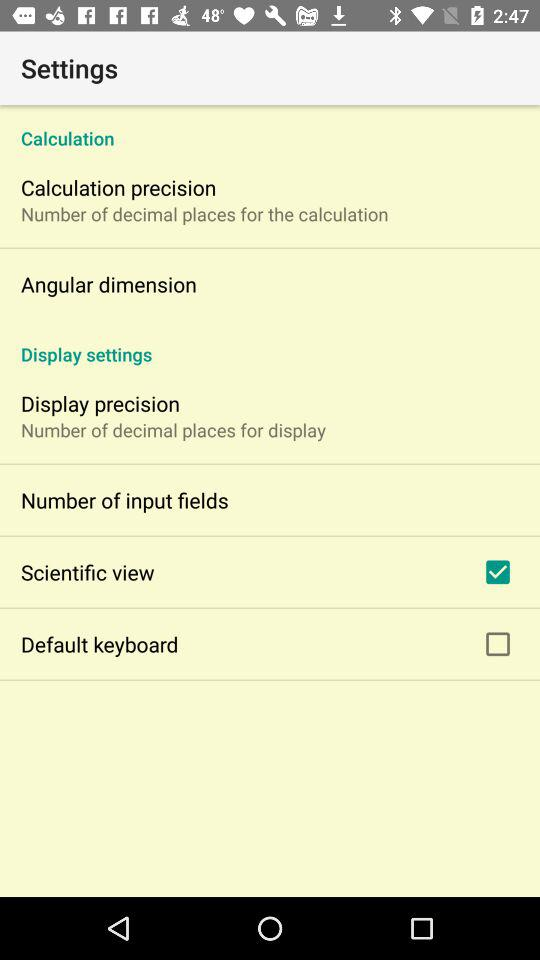What is the setting for the scientific view? The setting for the scientific view is "on". 